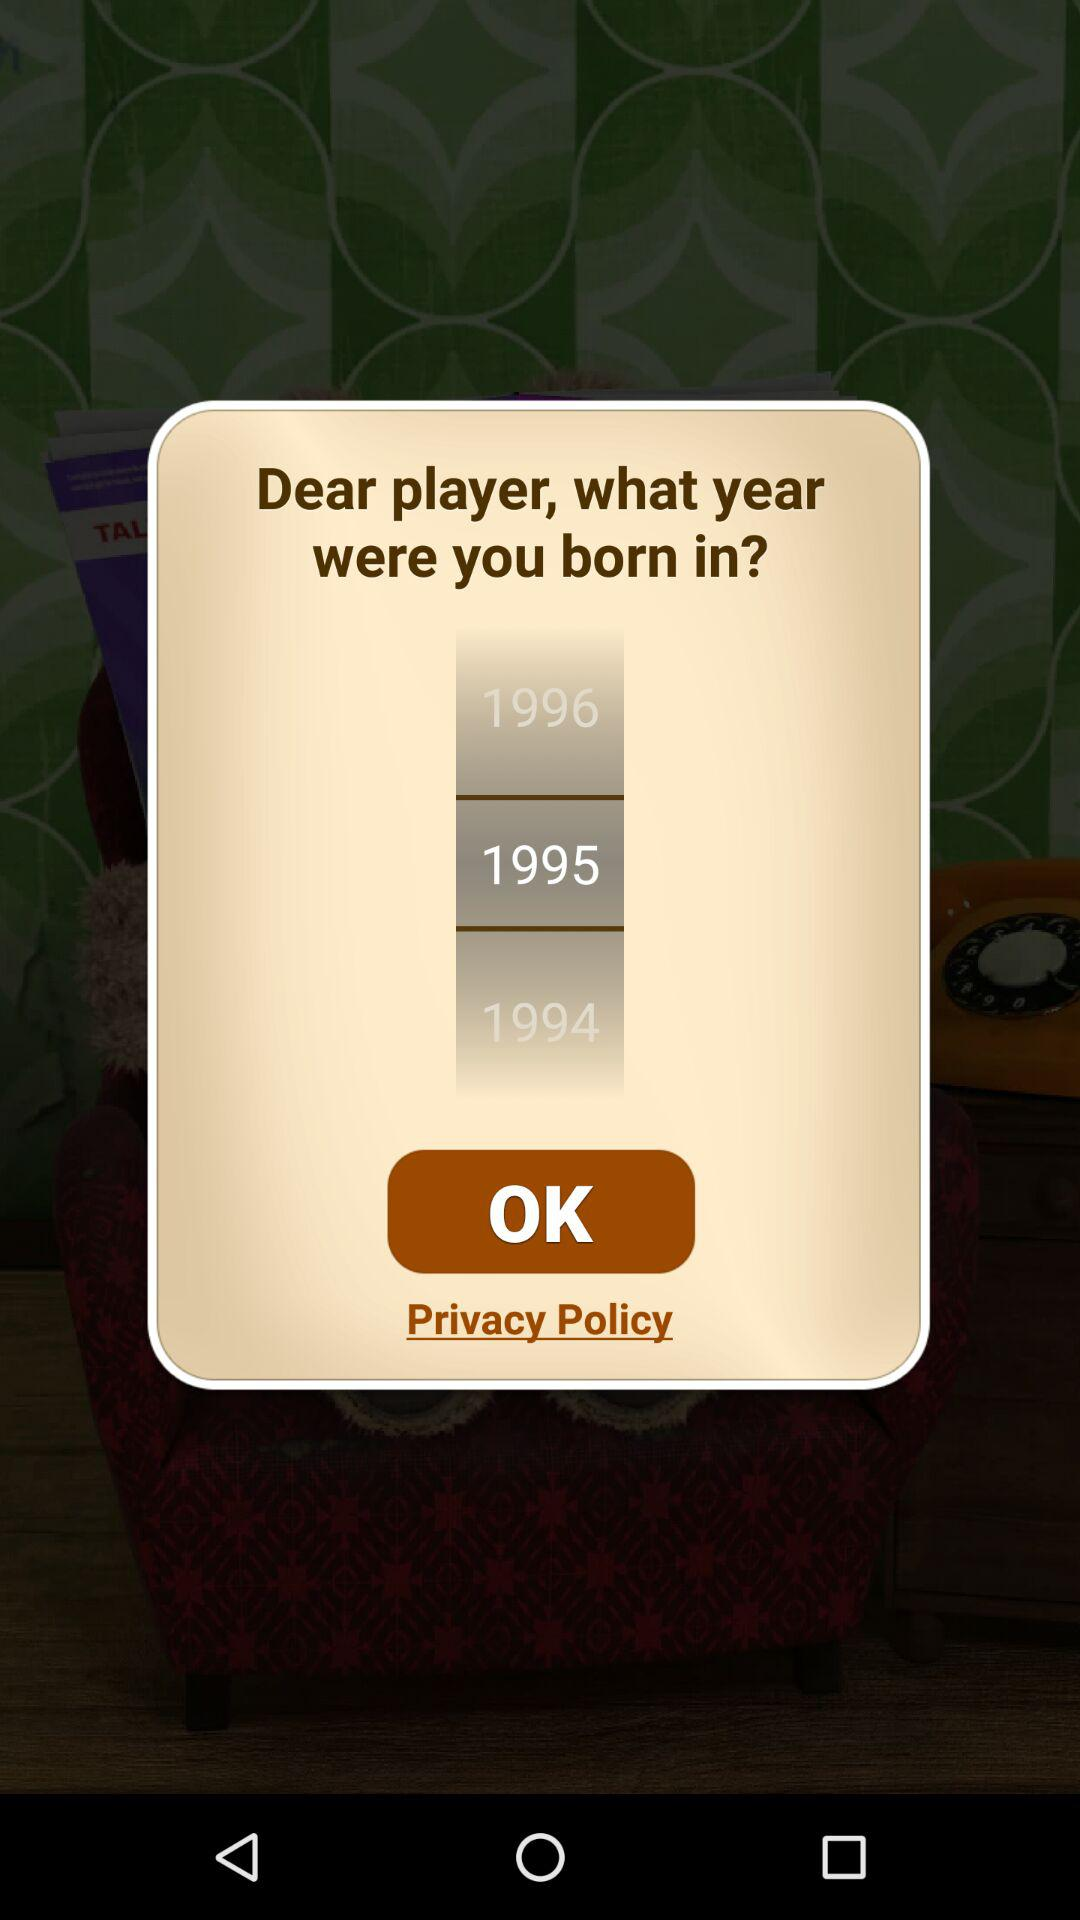What year is being highlighted? The year being highlighted is 1995. 